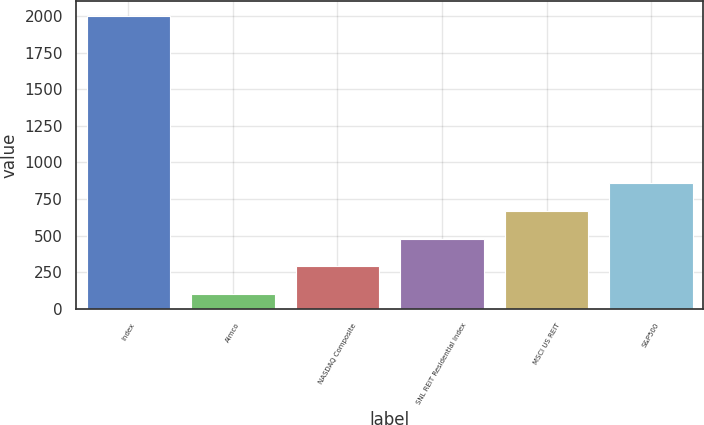Convert chart. <chart><loc_0><loc_0><loc_500><loc_500><bar_chart><fcel>Index<fcel>Aimco<fcel>NASDAQ Composite<fcel>SNL REIT Residential Index<fcel>MSCI US REIT<fcel>S&P500<nl><fcel>2003<fcel>100<fcel>290.3<fcel>480.6<fcel>670.9<fcel>861.2<nl></chart> 